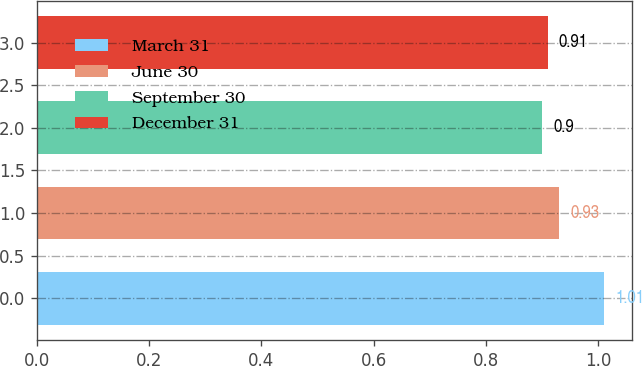Convert chart to OTSL. <chart><loc_0><loc_0><loc_500><loc_500><bar_chart><fcel>March 31<fcel>June 30<fcel>September 30<fcel>December 31<nl><fcel>1.01<fcel>0.93<fcel>0.9<fcel>0.91<nl></chart> 